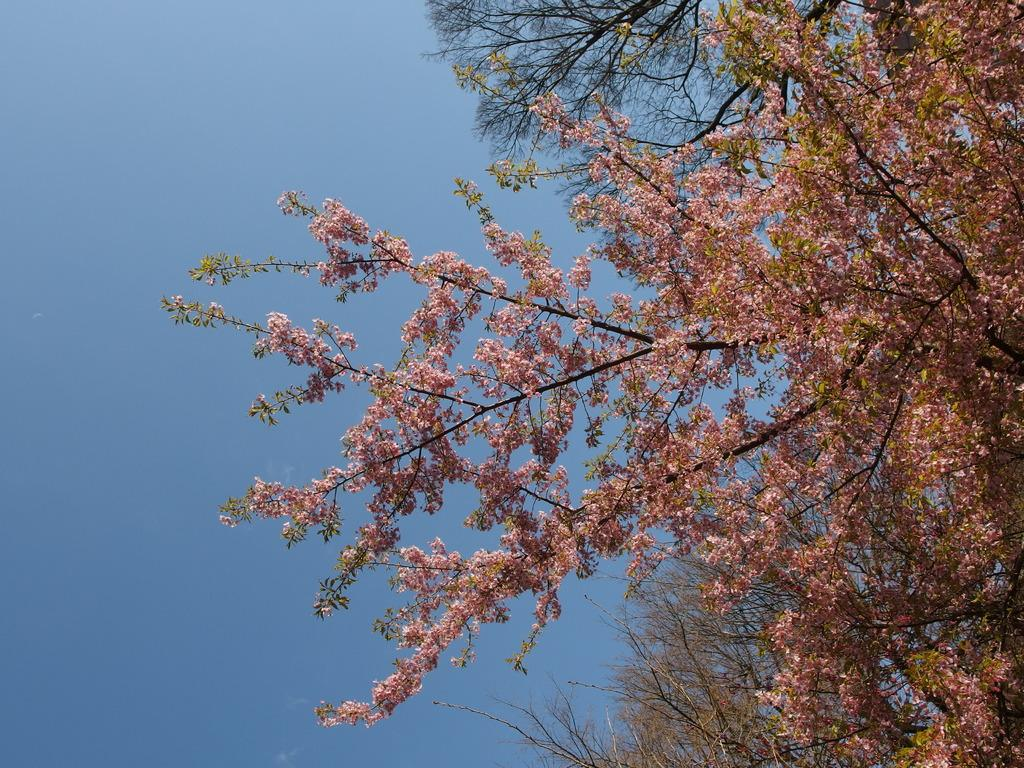What type of vegetation can be seen in the image? There are trees and flowers in the image. What color is the sky in the image? The sky is blue in the image. What type of competition is taking place in the image? There is no competition present in the image; it features trees, flowers, and a blue sky. What type of flag is visible in the image? There is no flag present in the image. 